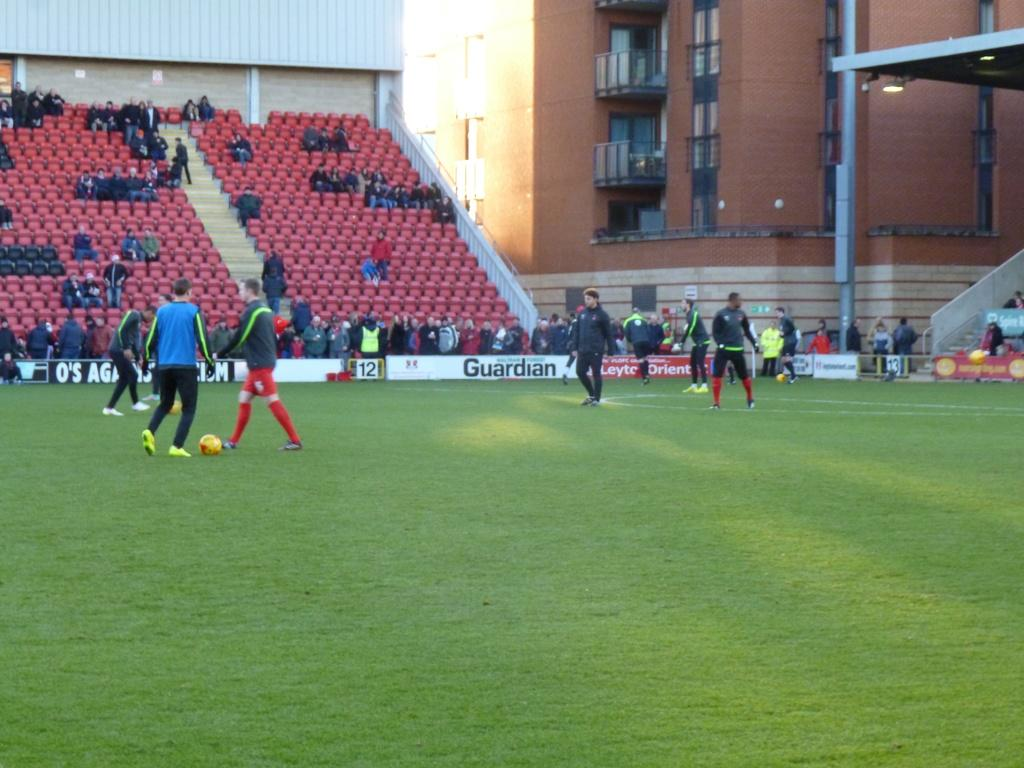<image>
Summarize the visual content of the image. A group of foot ball players practicing in the field with the advertisement Guardian behind it 